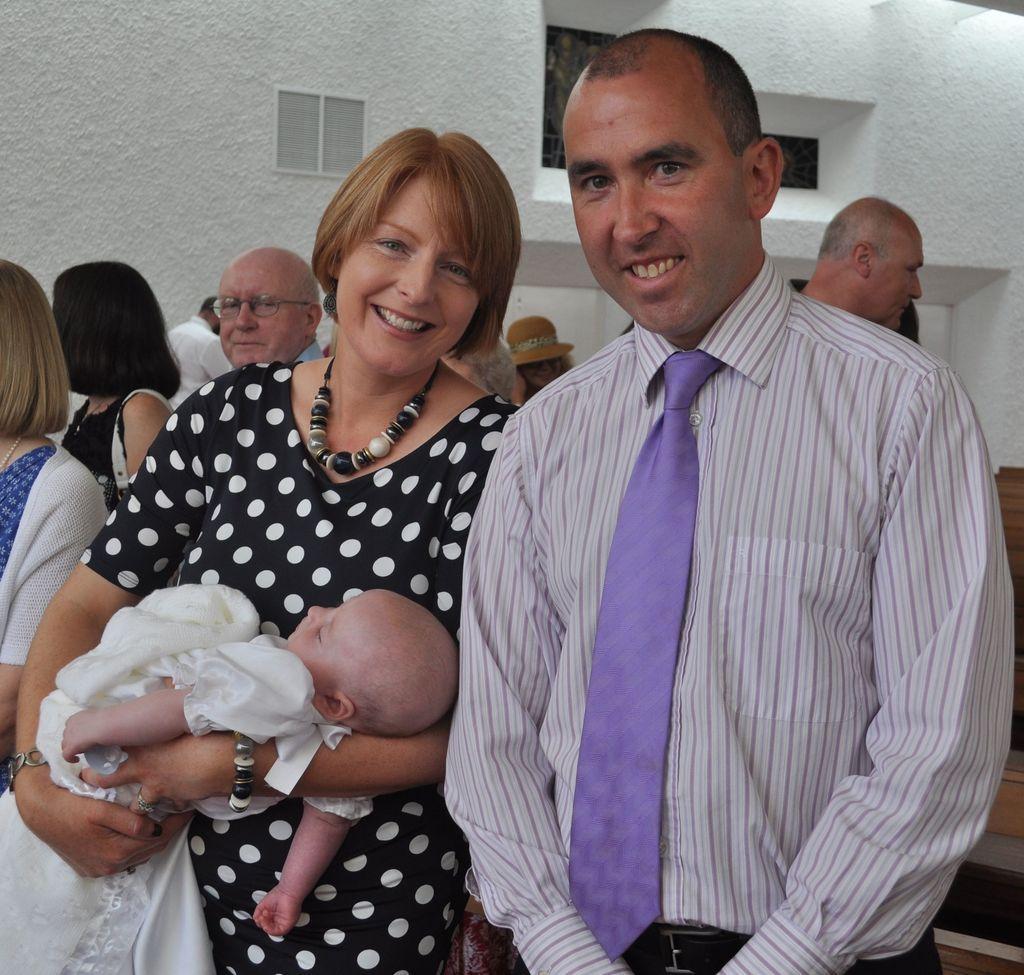In one or two sentences, can you explain what this image depicts? In this image we can see a few people, among them, one person is carrying a baby and in the background we can see a building. 